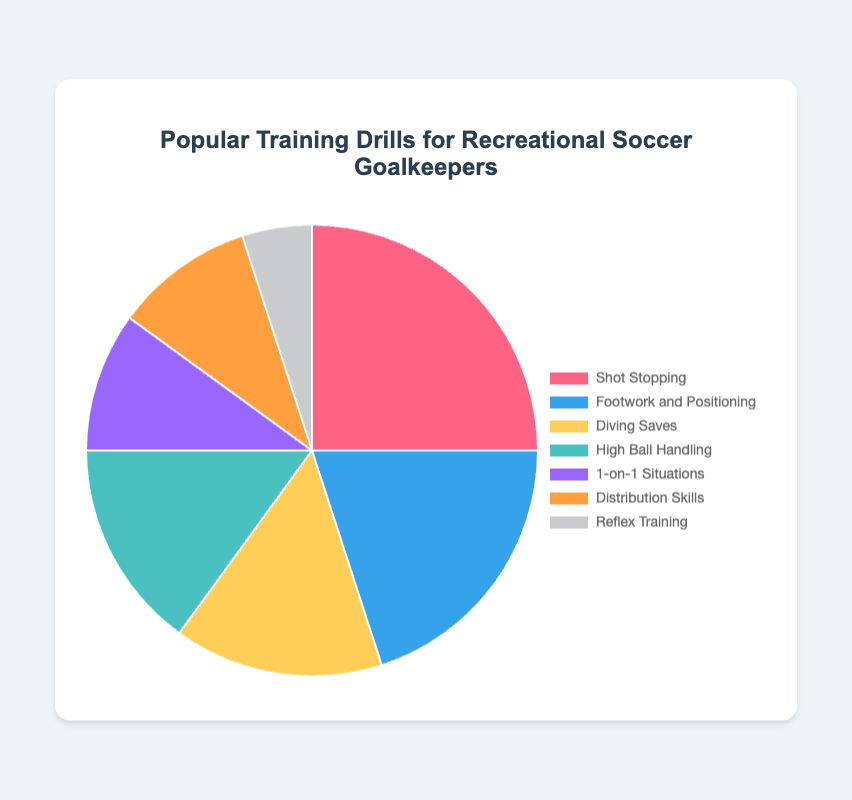What is the most popular training drill for recreational soccer goalkeepers according to the pie chart? The pie chart shows different training drills and their corresponding percentages. The drill with the highest percentage is the most popular. By looking at the chart, "Shot Stopping" has the highest percentage at 25%.
Answer: Shot Stopping Which training drill occupies the smallest portion of the pie chart? To find the smallest portion, observe the drill with the least percentage. "Reflex Training" has the smallest portion at 5%.
Answer: Reflex Training How much more percentage does "Shot Stopping" have compared to "1-on-1 Situations"? "Shot Stopping" has 25%, and "1-on-1 Situations" has 10%. The difference is calculated by subtracting the smaller percentage from the larger one, 25% - 10% = 15%.
Answer: 15% What is the combined percentage of "Diving Saves" and "High Ball Handling"? Both "Diving Saves" and "High Ball Handling" have 15% each. Adding these together, 15% + 15% = 30%.
Answer: 30% Which drill category sums up to exactly one-third of the entire pie chart? The entire pie chart is 100%. One-third of the pie chart would be 100% / 3 = 33.33%. Adding "Shot Stopping" (25%) and "Reflex Training" (5%), we get 25% + 5% = 30%. Adding "1-on-1 Situations" (10%) alone does not reach a third. Hence, no category sums up to exactly one-third.
Answer: None Compare "Footwork and Positioning" and "Distribution Skills" in terms of their popularity. "Footwork and Positioning" has 20%, while "Distribution Skills" has 10%. This indicates that "Footwork and Positioning" is more popular by 10%.
Answer: Footwork and Positioning Which color represents "High Ball Handling" in the chart? Observe the visual attributes of the pie chart. The segment labeled "High Ball Handling" corresponds to a specific color. According to the data, it is represented by a teal color.
Answer: Teal 